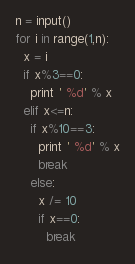Convert code to text. <code><loc_0><loc_0><loc_500><loc_500><_Python_>n = input()
for i in range(1,n):
  x = i
  if x%3==0:
    print ' %d' % x
  elif x<=n:
    if x%10==3:
      print ' %d' % x
      break
    else:
      x /= 10
      if x==0:
        break</code> 